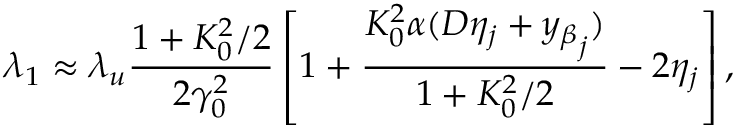Convert formula to latex. <formula><loc_0><loc_0><loc_500><loc_500>\lambda _ { 1 } \approx \lambda _ { u } \frac { 1 + K _ { 0 } ^ { 2 } / 2 } { 2 \gamma _ { 0 } ^ { 2 } } \left [ 1 + \frac { K _ { 0 } ^ { 2 } \alpha ( D \eta _ { j } + { y _ { \beta } } _ { j } ) } { 1 + K _ { 0 } ^ { 2 } / 2 } - 2 \eta _ { j } \right ] ,</formula> 